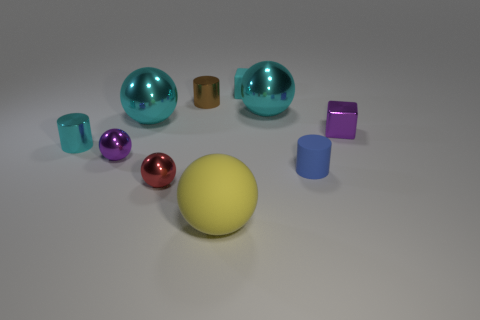What is the size of the yellow rubber object?
Ensure brevity in your answer.  Large. The yellow thing that is the same shape as the red metal thing is what size?
Provide a short and direct response. Large. Do the tiny matte cylinder and the big ball in front of the tiny red ball have the same color?
Offer a very short reply. No. There is a purple ball; are there any small brown shiny cylinders to the right of it?
Your answer should be very brief. Yes. Is the purple block made of the same material as the cyan block?
Your answer should be compact. No. What material is the cyan cube that is the same size as the brown metal cylinder?
Your answer should be very brief. Rubber. How many objects are tiny blocks behind the brown cylinder or large yellow metallic cylinders?
Ensure brevity in your answer.  1. Is the number of cyan matte blocks in front of the tiny cyan rubber cube the same as the number of big blue spheres?
Provide a short and direct response. Yes. The cylinder that is right of the purple sphere and behind the blue rubber cylinder is what color?
Your response must be concise. Brown. How many cubes are either small purple metallic objects or small rubber objects?
Keep it short and to the point. 2. 